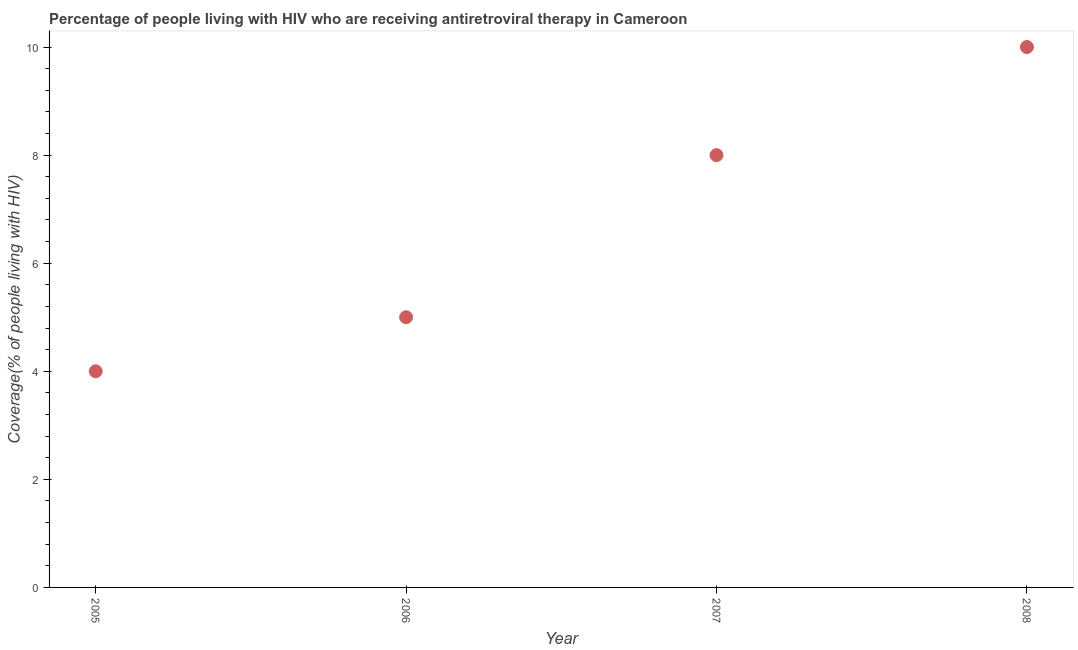What is the antiretroviral therapy coverage in 2006?
Provide a succinct answer. 5. Across all years, what is the maximum antiretroviral therapy coverage?
Make the answer very short. 10. Across all years, what is the minimum antiretroviral therapy coverage?
Offer a terse response. 4. What is the sum of the antiretroviral therapy coverage?
Your answer should be very brief. 27. What is the difference between the antiretroviral therapy coverage in 2005 and 2007?
Your answer should be very brief. -4. What is the average antiretroviral therapy coverage per year?
Give a very brief answer. 6.75. What is the median antiretroviral therapy coverage?
Provide a succinct answer. 6.5. Do a majority of the years between 2005 and 2008 (inclusive) have antiretroviral therapy coverage greater than 6.4 %?
Give a very brief answer. No. What is the ratio of the antiretroviral therapy coverage in 2006 to that in 2008?
Give a very brief answer. 0.5. What is the difference between the highest and the second highest antiretroviral therapy coverage?
Give a very brief answer. 2. Is the sum of the antiretroviral therapy coverage in 2006 and 2007 greater than the maximum antiretroviral therapy coverage across all years?
Your answer should be very brief. Yes. What is the difference between the highest and the lowest antiretroviral therapy coverage?
Provide a short and direct response. 6. How many dotlines are there?
Ensure brevity in your answer.  1. How many years are there in the graph?
Give a very brief answer. 4. What is the difference between two consecutive major ticks on the Y-axis?
Give a very brief answer. 2. Does the graph contain grids?
Your response must be concise. No. What is the title of the graph?
Give a very brief answer. Percentage of people living with HIV who are receiving antiretroviral therapy in Cameroon. What is the label or title of the X-axis?
Provide a short and direct response. Year. What is the label or title of the Y-axis?
Ensure brevity in your answer.  Coverage(% of people living with HIV). What is the Coverage(% of people living with HIV) in 2005?
Provide a succinct answer. 4. What is the Coverage(% of people living with HIV) in 2006?
Provide a succinct answer. 5. What is the difference between the Coverage(% of people living with HIV) in 2005 and 2006?
Ensure brevity in your answer.  -1. What is the difference between the Coverage(% of people living with HIV) in 2005 and 2007?
Your answer should be compact. -4. What is the difference between the Coverage(% of people living with HIV) in 2007 and 2008?
Offer a very short reply. -2. What is the ratio of the Coverage(% of people living with HIV) in 2006 to that in 2007?
Make the answer very short. 0.62. What is the ratio of the Coverage(% of people living with HIV) in 2006 to that in 2008?
Your answer should be very brief. 0.5. What is the ratio of the Coverage(% of people living with HIV) in 2007 to that in 2008?
Make the answer very short. 0.8. 